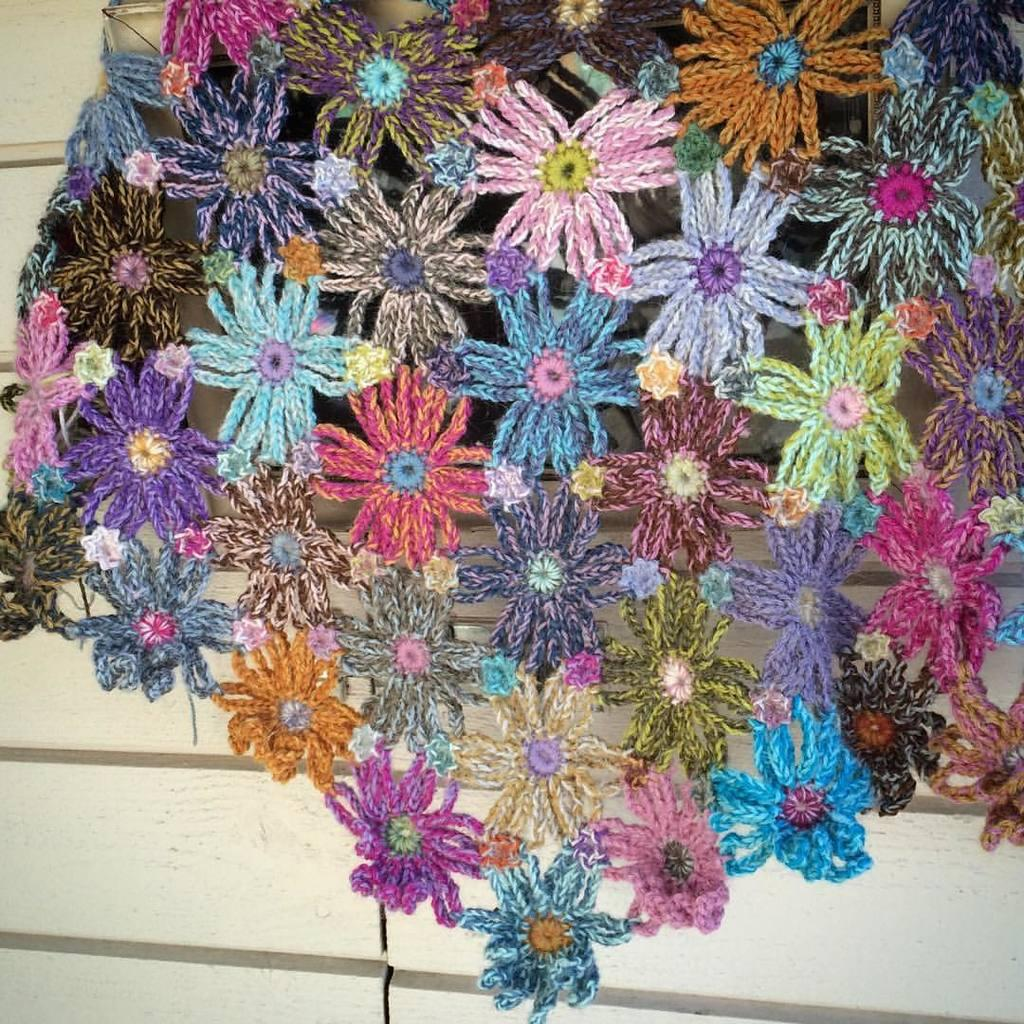What is the main subject in the center of the image? There is a woolen craft in the center of the image. What can be seen in the background of the image? There is a wall visible in the background of the image. Are there any other objects or features in the background of the image? Yes, there are some other unspecified items in the background of the image. Can you see any planes flying in the image? No, there are no planes visible in the image. Is there a snake present in the woolen craft? There is no snake mentioned or visible in the image; it features a woolen craft. 